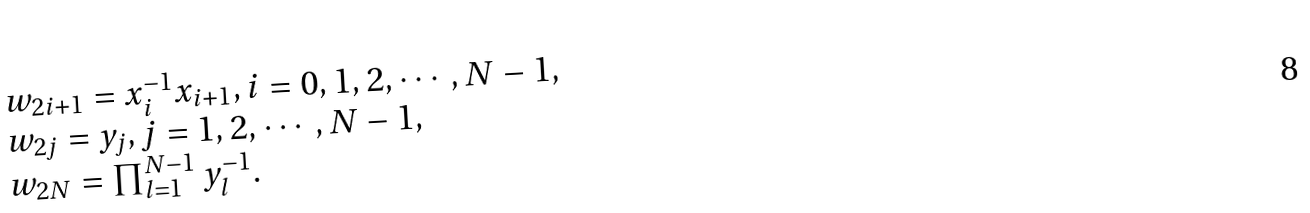<formula> <loc_0><loc_0><loc_500><loc_500>\begin{array} { l } { { w _ { 2 i + 1 } = x _ { i } ^ { - 1 } x _ { i + 1 } , i = 0 , 1 , 2 , \cdots , N - 1 , } } \\ { { w _ { 2 j } = y _ { j } , j = 1 , 2 , \cdots , N - 1 , } } \\ { { w _ { 2 N } = \prod _ { l = 1 } ^ { N - 1 } y _ { l } ^ { - 1 } . } } \end{array}</formula> 